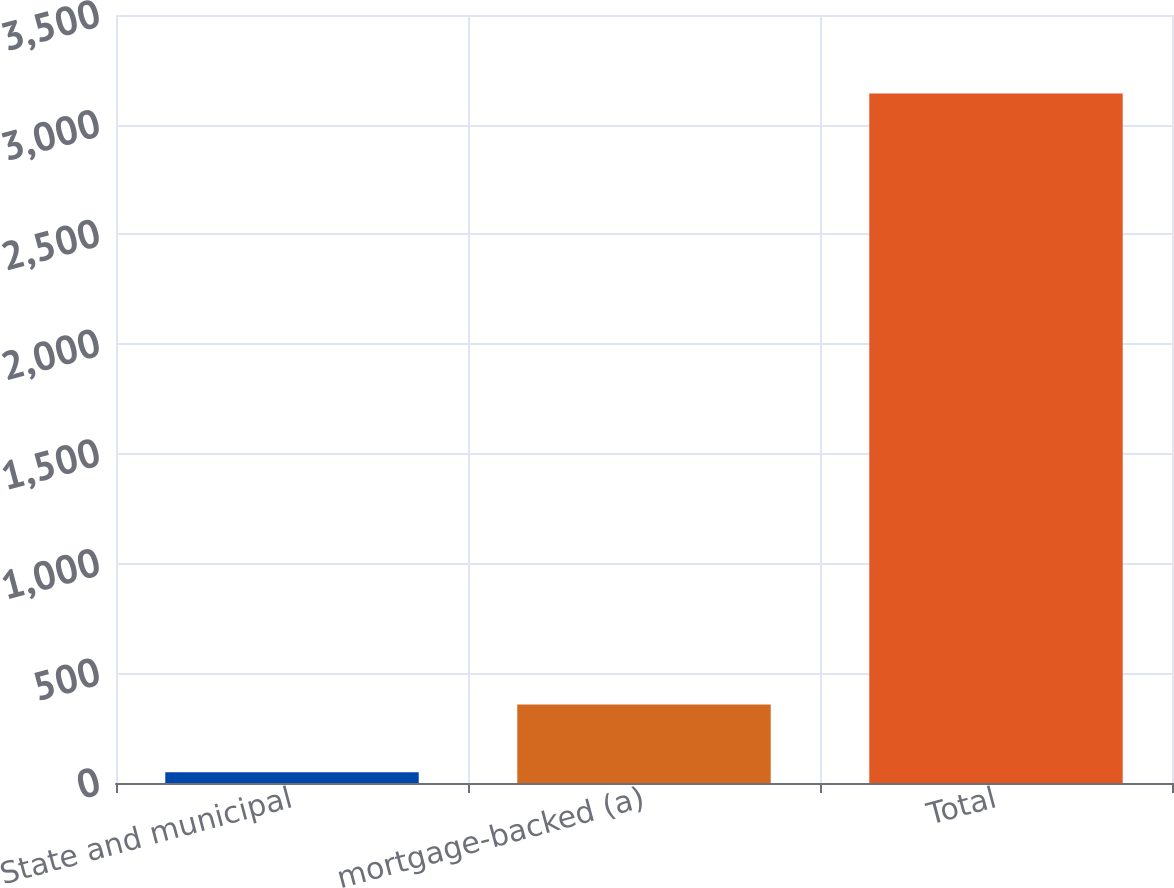Convert chart to OTSL. <chart><loc_0><loc_0><loc_500><loc_500><bar_chart><fcel>State and municipal<fcel>mortgage-backed (a)<fcel>Total<nl><fcel>49<fcel>358.3<fcel>3142<nl></chart> 